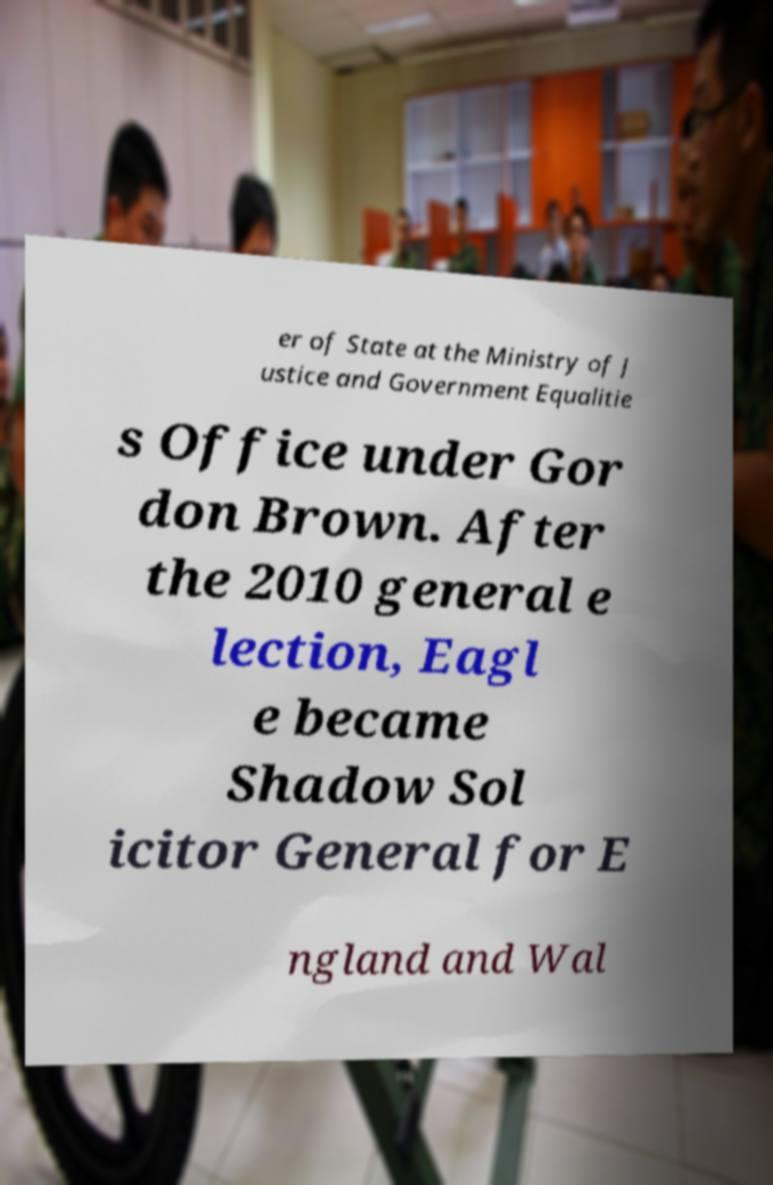What messages or text are displayed in this image? I need them in a readable, typed format. er of State at the Ministry of J ustice and Government Equalitie s Office under Gor don Brown. After the 2010 general e lection, Eagl e became Shadow Sol icitor General for E ngland and Wal 